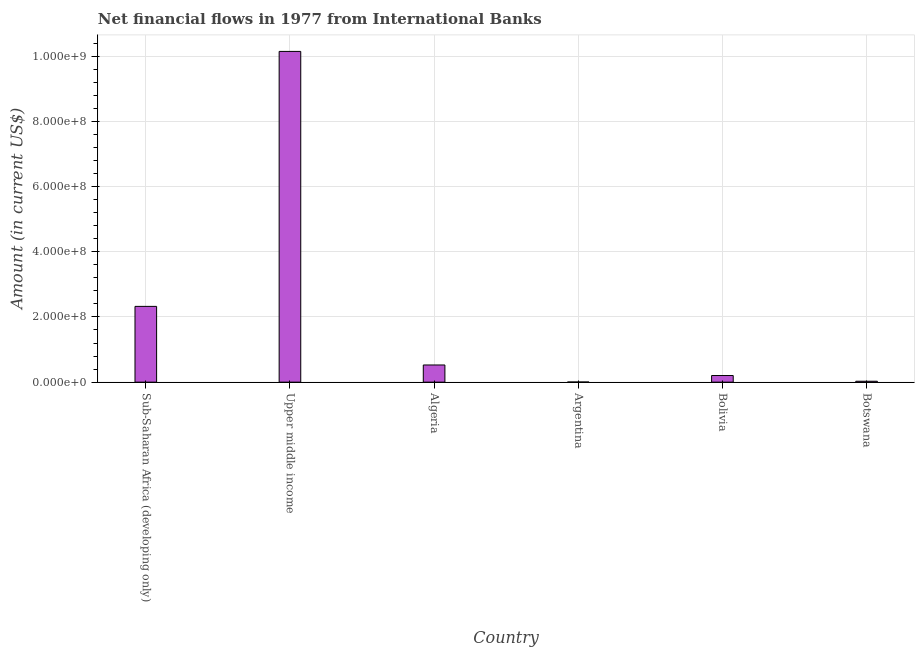Does the graph contain grids?
Make the answer very short. Yes. What is the title of the graph?
Provide a succinct answer. Net financial flows in 1977 from International Banks. What is the label or title of the X-axis?
Ensure brevity in your answer.  Country. What is the label or title of the Y-axis?
Provide a succinct answer. Amount (in current US$). What is the net financial flows from ibrd in Upper middle income?
Offer a terse response. 1.01e+09. Across all countries, what is the maximum net financial flows from ibrd?
Offer a very short reply. 1.01e+09. Across all countries, what is the minimum net financial flows from ibrd?
Your answer should be very brief. 3.61e+05. In which country was the net financial flows from ibrd maximum?
Provide a short and direct response. Upper middle income. In which country was the net financial flows from ibrd minimum?
Ensure brevity in your answer.  Argentina. What is the sum of the net financial flows from ibrd?
Provide a succinct answer. 1.32e+09. What is the difference between the net financial flows from ibrd in Botswana and Sub-Saharan Africa (developing only)?
Give a very brief answer. -2.30e+08. What is the average net financial flows from ibrd per country?
Your answer should be very brief. 2.21e+08. What is the median net financial flows from ibrd?
Make the answer very short. 3.65e+07. What is the ratio of the net financial flows from ibrd in Algeria to that in Argentina?
Ensure brevity in your answer.  145.88. Is the net financial flows from ibrd in Algeria less than that in Argentina?
Offer a terse response. No. Is the difference between the net financial flows from ibrd in Algeria and Upper middle income greater than the difference between any two countries?
Your answer should be compact. No. What is the difference between the highest and the second highest net financial flows from ibrd?
Ensure brevity in your answer.  7.82e+08. Is the sum of the net financial flows from ibrd in Botswana and Upper middle income greater than the maximum net financial flows from ibrd across all countries?
Provide a succinct answer. Yes. What is the difference between the highest and the lowest net financial flows from ibrd?
Keep it short and to the point. 1.01e+09. How many bars are there?
Ensure brevity in your answer.  6. How many countries are there in the graph?
Your answer should be very brief. 6. What is the difference between two consecutive major ticks on the Y-axis?
Make the answer very short. 2.00e+08. What is the Amount (in current US$) in Sub-Saharan Africa (developing only)?
Give a very brief answer. 2.32e+08. What is the Amount (in current US$) of Upper middle income?
Ensure brevity in your answer.  1.01e+09. What is the Amount (in current US$) of Algeria?
Your answer should be very brief. 5.27e+07. What is the Amount (in current US$) of Argentina?
Offer a terse response. 3.61e+05. What is the Amount (in current US$) in Bolivia?
Your answer should be very brief. 2.03e+07. What is the Amount (in current US$) of Botswana?
Offer a very short reply. 2.80e+06. What is the difference between the Amount (in current US$) in Sub-Saharan Africa (developing only) and Upper middle income?
Give a very brief answer. -7.82e+08. What is the difference between the Amount (in current US$) in Sub-Saharan Africa (developing only) and Algeria?
Ensure brevity in your answer.  1.80e+08. What is the difference between the Amount (in current US$) in Sub-Saharan Africa (developing only) and Argentina?
Provide a short and direct response. 2.32e+08. What is the difference between the Amount (in current US$) in Sub-Saharan Africa (developing only) and Bolivia?
Make the answer very short. 2.12e+08. What is the difference between the Amount (in current US$) in Sub-Saharan Africa (developing only) and Botswana?
Provide a short and direct response. 2.30e+08. What is the difference between the Amount (in current US$) in Upper middle income and Algeria?
Offer a very short reply. 9.62e+08. What is the difference between the Amount (in current US$) in Upper middle income and Argentina?
Make the answer very short. 1.01e+09. What is the difference between the Amount (in current US$) in Upper middle income and Bolivia?
Your response must be concise. 9.94e+08. What is the difference between the Amount (in current US$) in Upper middle income and Botswana?
Keep it short and to the point. 1.01e+09. What is the difference between the Amount (in current US$) in Algeria and Argentina?
Give a very brief answer. 5.23e+07. What is the difference between the Amount (in current US$) in Algeria and Bolivia?
Your answer should be very brief. 3.23e+07. What is the difference between the Amount (in current US$) in Algeria and Botswana?
Provide a short and direct response. 4.99e+07. What is the difference between the Amount (in current US$) in Argentina and Bolivia?
Your answer should be compact. -2.00e+07. What is the difference between the Amount (in current US$) in Argentina and Botswana?
Give a very brief answer. -2.44e+06. What is the difference between the Amount (in current US$) in Bolivia and Botswana?
Your answer should be very brief. 1.75e+07. What is the ratio of the Amount (in current US$) in Sub-Saharan Africa (developing only) to that in Upper middle income?
Offer a very short reply. 0.23. What is the ratio of the Amount (in current US$) in Sub-Saharan Africa (developing only) to that in Algeria?
Ensure brevity in your answer.  4.41. What is the ratio of the Amount (in current US$) in Sub-Saharan Africa (developing only) to that in Argentina?
Keep it short and to the point. 643.93. What is the ratio of the Amount (in current US$) in Sub-Saharan Africa (developing only) to that in Bolivia?
Make the answer very short. 11.43. What is the ratio of the Amount (in current US$) in Sub-Saharan Africa (developing only) to that in Botswana?
Provide a succinct answer. 83.08. What is the ratio of the Amount (in current US$) in Upper middle income to that in Algeria?
Keep it short and to the point. 19.27. What is the ratio of the Amount (in current US$) in Upper middle income to that in Argentina?
Offer a very short reply. 2810.73. What is the ratio of the Amount (in current US$) in Upper middle income to that in Bolivia?
Make the answer very short. 49.87. What is the ratio of the Amount (in current US$) in Upper middle income to that in Botswana?
Ensure brevity in your answer.  362.64. What is the ratio of the Amount (in current US$) in Algeria to that in Argentina?
Provide a short and direct response. 145.88. What is the ratio of the Amount (in current US$) in Algeria to that in Bolivia?
Your answer should be very brief. 2.59. What is the ratio of the Amount (in current US$) in Algeria to that in Botswana?
Your answer should be very brief. 18.82. What is the ratio of the Amount (in current US$) in Argentina to that in Bolivia?
Give a very brief answer. 0.02. What is the ratio of the Amount (in current US$) in Argentina to that in Botswana?
Make the answer very short. 0.13. What is the ratio of the Amount (in current US$) in Bolivia to that in Botswana?
Provide a short and direct response. 7.27. 